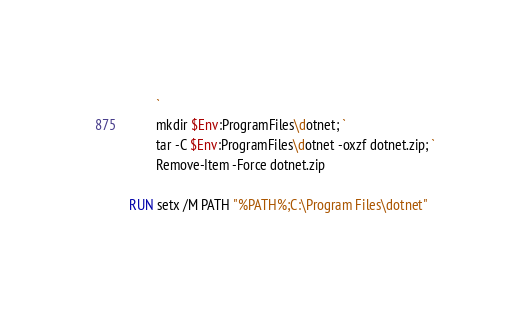Convert code to text. <code><loc_0><loc_0><loc_500><loc_500><_Dockerfile_>        `
        mkdir $Env:ProgramFiles\dotnet; `
        tar -C $Env:ProgramFiles\dotnet -oxzf dotnet.zip; `
        Remove-Item -Force dotnet.zip

RUN setx /M PATH "%PATH%;C:\Program Files\dotnet"
</code> 